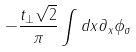<formula> <loc_0><loc_0><loc_500><loc_500>- \frac { t _ { \perp } \sqrt { 2 } } \pi \int d x \partial _ { x } \phi _ { \sigma }</formula> 